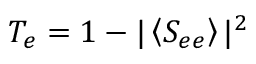Convert formula to latex. <formula><loc_0><loc_0><loc_500><loc_500>T _ { e } = 1 - | \left \langle { S _ { e e } } \right \rangle | ^ { 2 }</formula> 